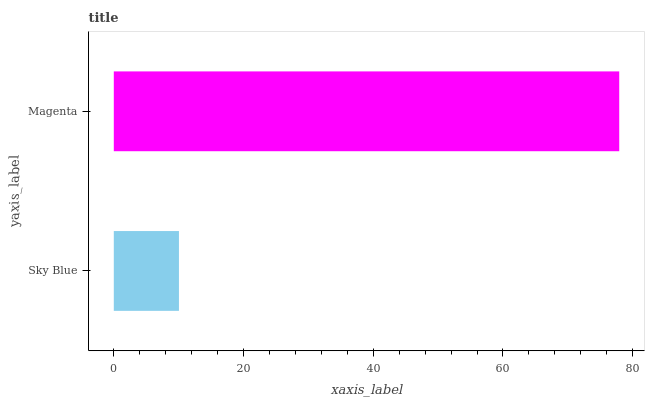Is Sky Blue the minimum?
Answer yes or no. Yes. Is Magenta the maximum?
Answer yes or no. Yes. Is Magenta the minimum?
Answer yes or no. No. Is Magenta greater than Sky Blue?
Answer yes or no. Yes. Is Sky Blue less than Magenta?
Answer yes or no. Yes. Is Sky Blue greater than Magenta?
Answer yes or no. No. Is Magenta less than Sky Blue?
Answer yes or no. No. Is Magenta the high median?
Answer yes or no. Yes. Is Sky Blue the low median?
Answer yes or no. Yes. Is Sky Blue the high median?
Answer yes or no. No. Is Magenta the low median?
Answer yes or no. No. 